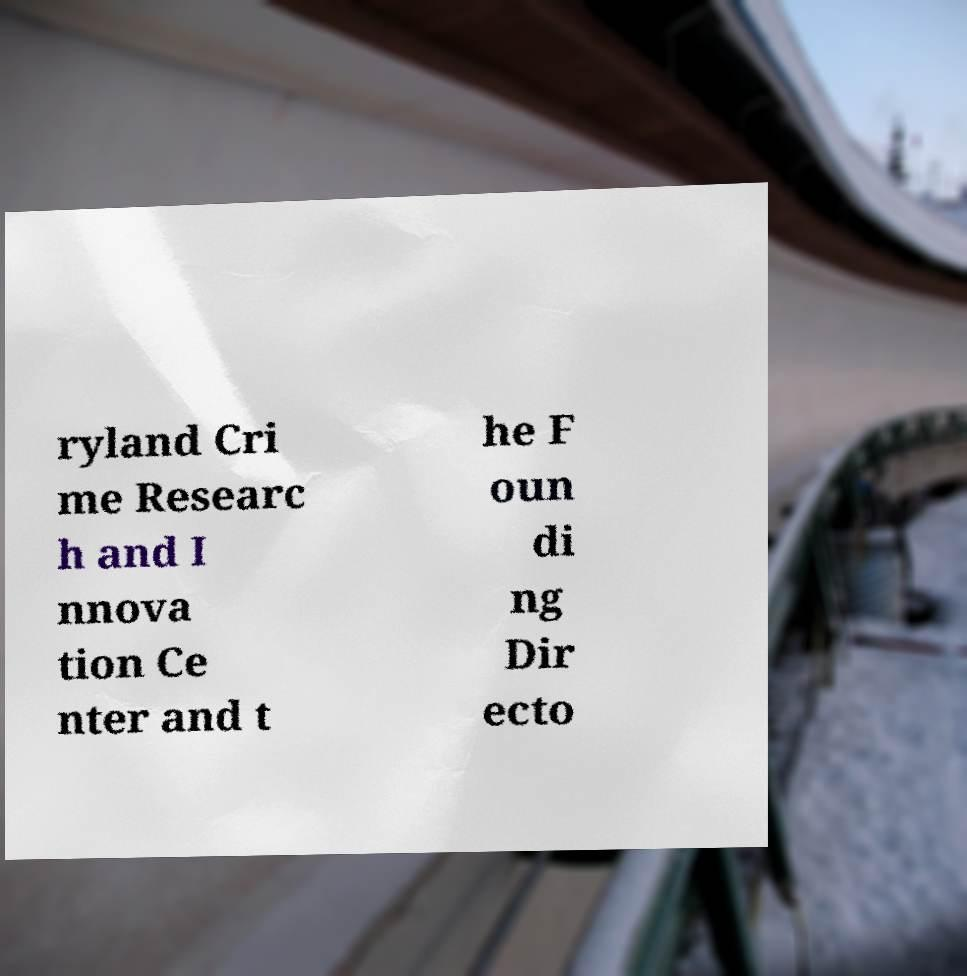For documentation purposes, I need the text within this image transcribed. Could you provide that? ryland Cri me Researc h and I nnova tion Ce nter and t he F oun di ng Dir ecto 